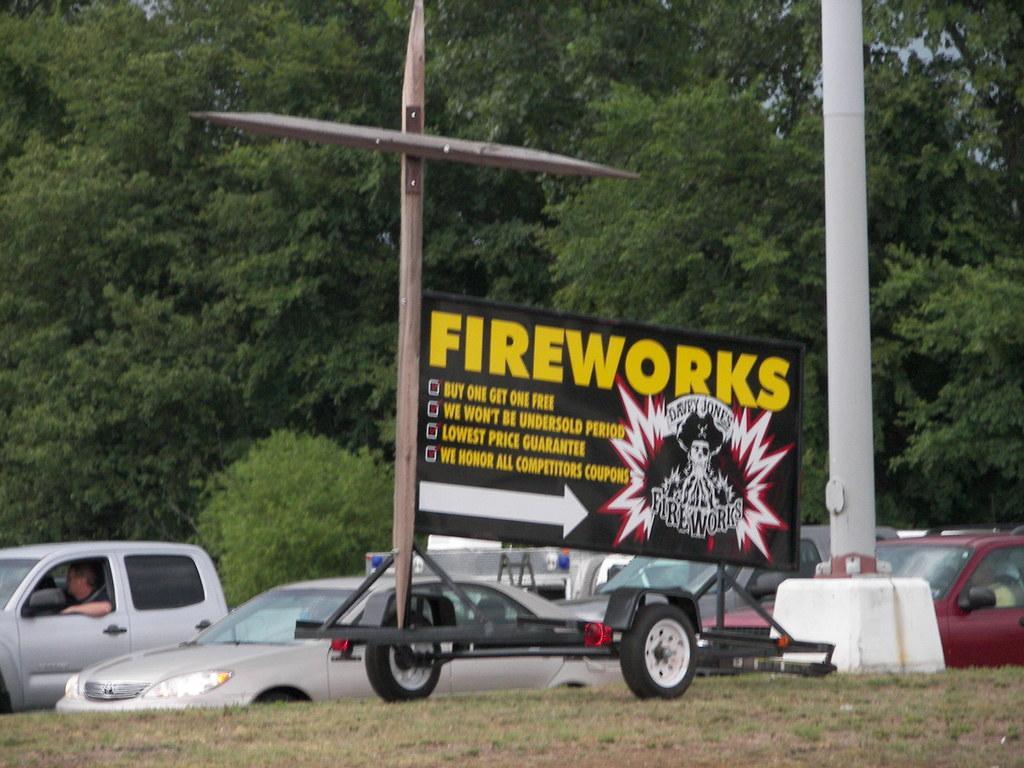Describe this image in one or two sentences. In this image I can see few vehicles. In front I can see a black color board attached to the pole and I can also see trees in green color and the sky is in blue color. 